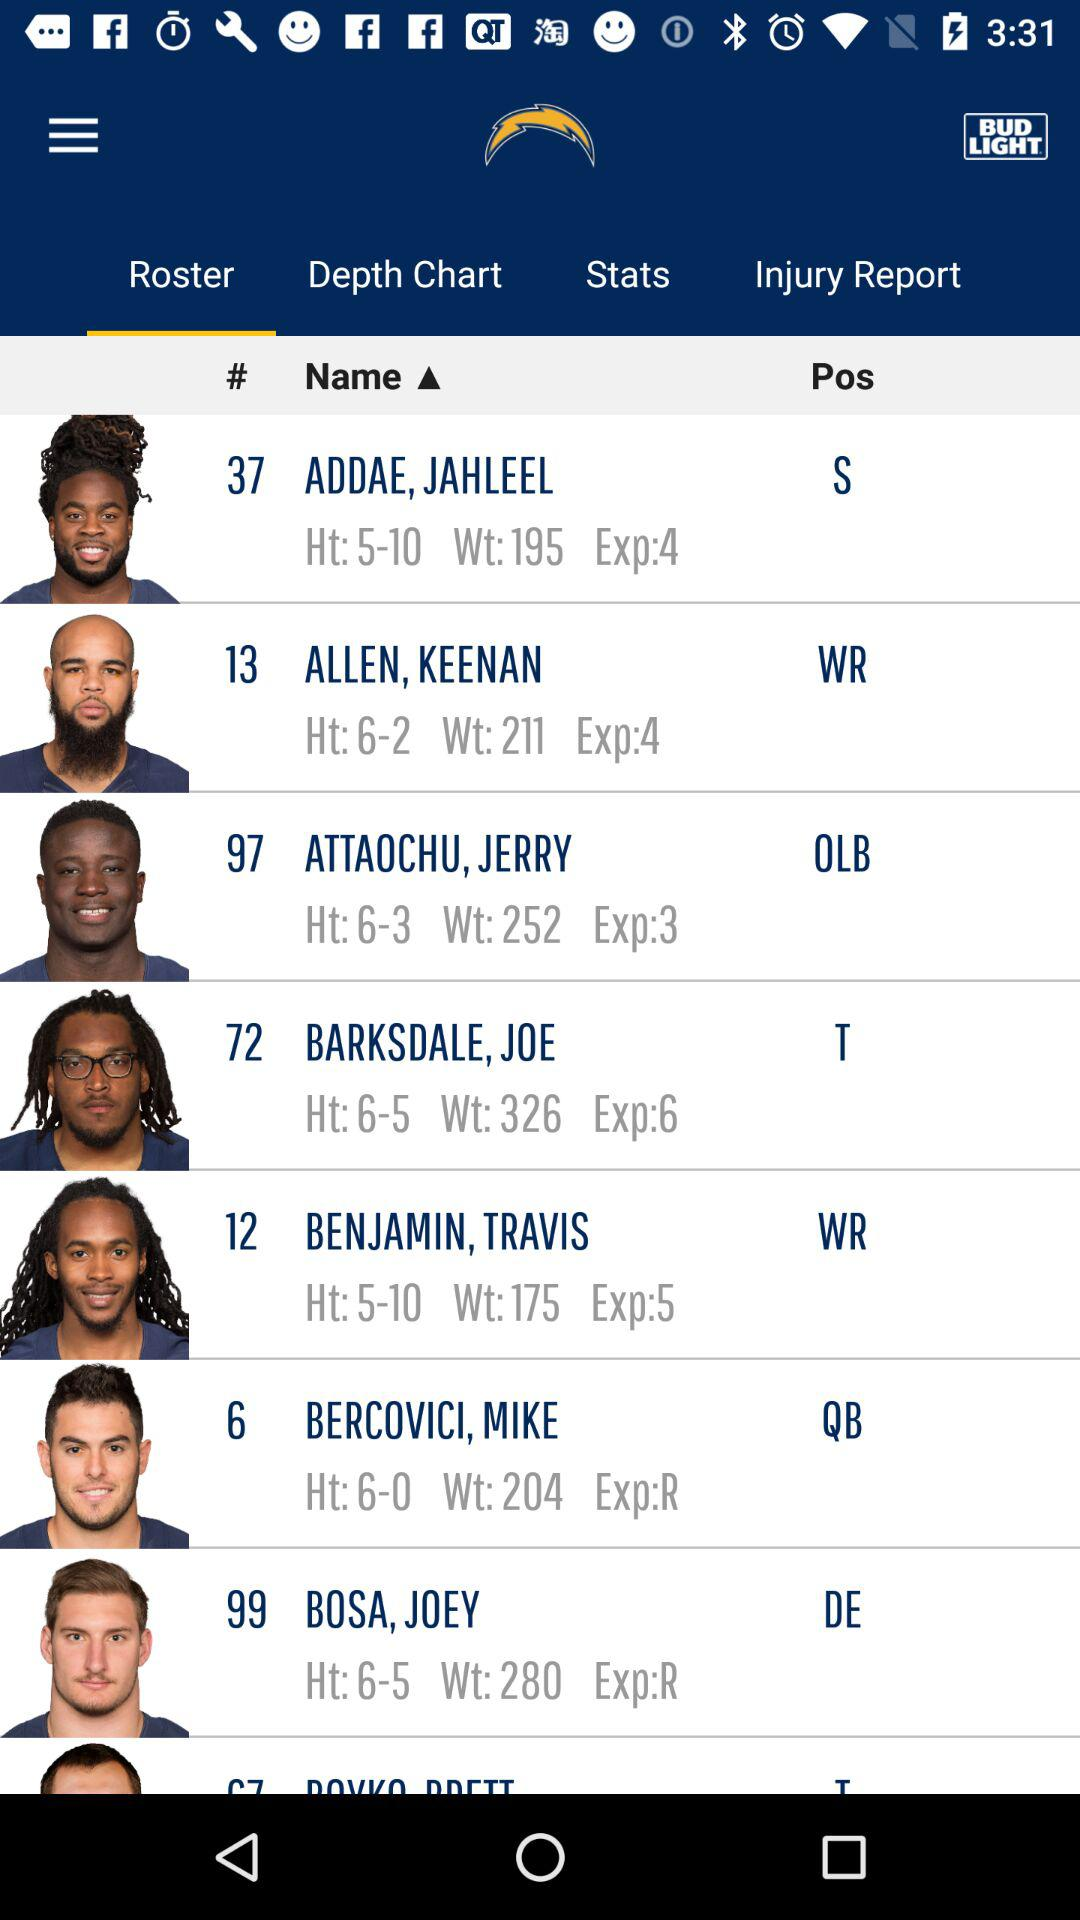What is the name of the player on roster number 6? The name of the player on roster number 6 is Bercovici, Mike. 